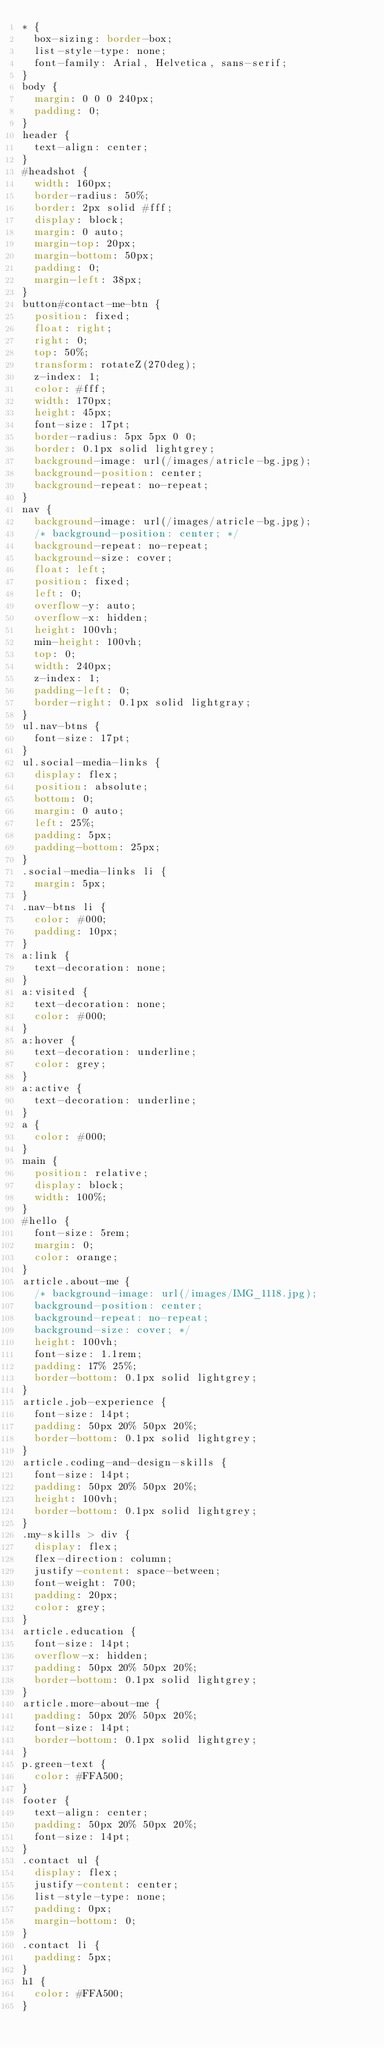Convert code to text. <code><loc_0><loc_0><loc_500><loc_500><_CSS_>* {
  box-sizing: border-box;
  list-style-type: none;
  font-family: Arial, Helvetica, sans-serif;
}
body {
  margin: 0 0 0 240px;
  padding: 0;
}
header {
  text-align: center;
}
#headshot {
  width: 160px;
  border-radius: 50%;
  border: 2px solid #fff;
  display: block;
  margin: 0 auto;
  margin-top: 20px;
  margin-bottom: 50px;
  padding: 0;
  margin-left: 38px;
}
button#contact-me-btn {
  position: fixed;
  float: right;
  right: 0;
  top: 50%;
  transform: rotateZ(270deg);
  z-index: 1;
  color: #fff;
  width: 170px;
  height: 45px;
  font-size: 17pt;
  border-radius: 5px 5px 0 0;
  border: 0.1px solid lightgrey;
  background-image: url(/images/atricle-bg.jpg);
  background-position: center;
  background-repeat: no-repeat;  
}
nav {
  background-image: url(/images/atricle-bg.jpg);
  /* background-position: center; */
  background-repeat: no-repeat;
  background-size: cover;
  float: left;
  position: fixed;
  left: 0;
  overflow-y: auto;
  overflow-x: hidden;
  height: 100vh;
  min-height: 100vh;
  top: 0;
  width: 240px;
  z-index: 1;
  padding-left: 0;
  border-right: 0.1px solid lightgray;
}
ul.nav-btns {
  font-size: 17pt;
}
ul.social-media-links {
  display: flex;
  position: absolute;
  bottom: 0;
  margin: 0 auto;
  left: 25%;
  padding: 5px;
  padding-bottom: 25px;
}
.social-media-links li {
  margin: 5px;
}
.nav-btns li {
  color: #000;
  padding: 10px;
}
a:link {
  text-decoration: none;
}
a:visited {
  text-decoration: none;
  color: #000;
}
a:hover {
  text-decoration: underline;
  color: grey;
}
a:active {
  text-decoration: underline;
}
a {
  color: #000;
}
main {
  position: relative;
  display: block;
  width: 100%;
}
#hello {
  font-size: 5rem;
  margin: 0;
  color: orange;
}
article.about-me {
  /* background-image: url(/images/IMG_1118.jpg);
  background-position: center;
  background-repeat: no-repeat;
  background-size: cover; */
  height: 100vh;
  font-size: 1.1rem;
  padding: 17% 25%;
  border-bottom: 0.1px solid lightgrey;
}
article.job-experience {
  font-size: 14pt;
  padding: 50px 20% 50px 20%;
  border-bottom: 0.1px solid lightgrey;
}
article.coding-and-design-skills {
  font-size: 14pt;
  padding: 50px 20% 50px 20%;
  height: 100vh;
  border-bottom: 0.1px solid lightgrey;
}
.my-skills > div {
  display: flex;
  flex-direction: column;
  justify-content: space-between;
  font-weight: 700;
  padding: 20px;
  color: grey;
}
article.education {
  font-size: 14pt;
  overflow-x: hidden;
  padding: 50px 20% 50px 20%;
  border-bottom: 0.1px solid lightgrey;
}
article.more-about-me {
  padding: 50px 20% 50px 20%;
  font-size: 14pt;
  border-bottom: 0.1px solid lightgrey;
}
p.green-text {
  color: #FFA500;
}
footer {
  text-align: center;
  padding: 50px 20% 50px 20%;
  font-size: 14pt;
}
.contact ul {
  display: flex;
  justify-content: center;
  list-style-type: none;
  padding: 0px;
  margin-bottom: 0;
}
.contact li {
  padding: 5px;
}
h1 {
  color: #FFA500;
}
</code> 